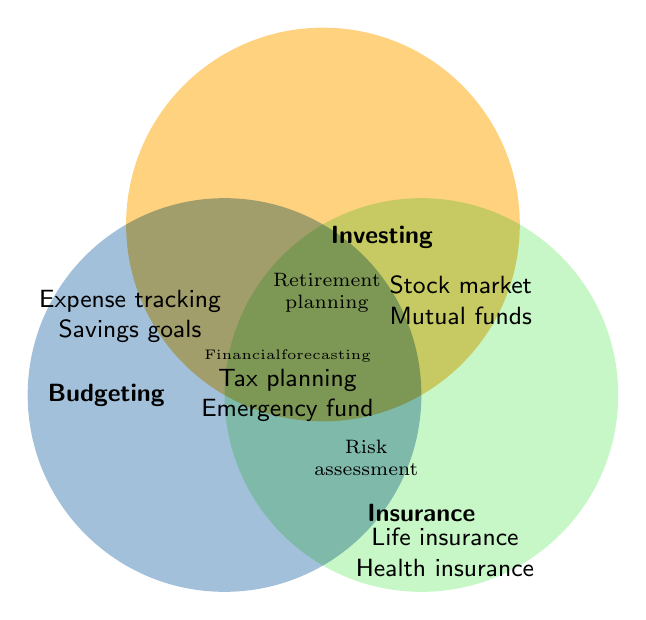Which budgeting components are mentioned? Identify the components listed in the Budgeting section of the Venn diagram.
Answer: Expense tracking, Savings goals Where would you find information on retirement planning? Locate the section within the Venn diagram that includes "Retirement Planning."
Answer: Investing What components are related to Insurance? Identify all text within the Insurance section of the Venn diagram.
Answer: Life insurance, Health insurance Which topics are covered by both Budgeting and Investing? Find the overlap section between Budgeting and Investing.
Answer: Tax planning, Emergency fund Is Risk assessment related to Investing, Insurance, or both? Look at the overlap section including Risk assessment.
Answer: Both Can you name a component unique to Investing? Identify a component listed only under Investing and not overlapping with other categories.
Answer: Mutual funds Which sections overlap in the area that includes Financial forecasting? Locate Financial forecasting and identify the intersecting categories.
Answer: Budgeting and Investing What is the common topic in all three sections? Determine the text that appears in the intersection of Budgeting, Investing, and Insurance sections.
Answer: Financial forecasting What's listed at the intersection of Budgeting and Insurance? Identify the sections where Budgeting and Insurance overlap.
Answer: No specific components listed How many components are exclusively mentioned under Budgeting? Count the components listed only in the Budgeting section without overlap.
Answer: 2 